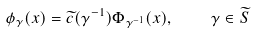Convert formula to latex. <formula><loc_0><loc_0><loc_500><loc_500>\phi _ { \gamma } ( x ) = \widetilde { c } ( \gamma ^ { - 1 } ) \Phi _ { \gamma ^ { - 1 } } ( x ) , \quad \gamma \in \widetilde { S }</formula> 